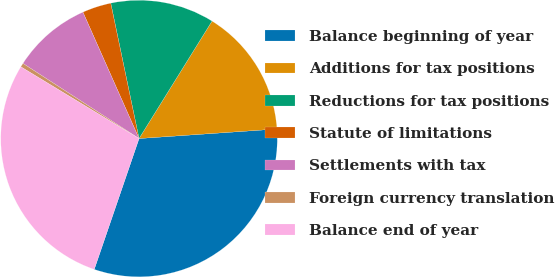Convert chart. <chart><loc_0><loc_0><loc_500><loc_500><pie_chart><fcel>Balance beginning of year<fcel>Additions for tax positions<fcel>Reductions for tax positions<fcel>Statute of limitations<fcel>Settlements with tax<fcel>Foreign currency translation<fcel>Balance end of year<nl><fcel>31.35%<fcel>15.05%<fcel>12.13%<fcel>3.37%<fcel>9.21%<fcel>0.46%<fcel>28.43%<nl></chart> 